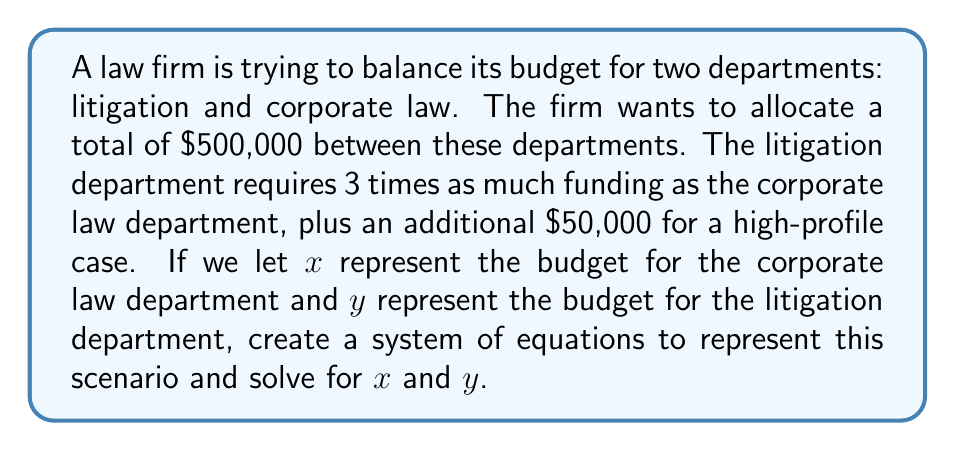Could you help me with this problem? Let's approach this step-by-step:

1) First, we need to set up our system of equations based on the given information:

   Equation 1: Total budget
   $x + y = 500000$

   Equation 2: Relationship between departments' budgets
   $y = 3x + 50000$

2) Now we have a system of two equations with two unknowns:

   $$\begin{cases}
   x + y = 500000 \\
   y = 3x + 50000
   \end{cases}$$

3) We can solve this system by substitution. Let's substitute the second equation into the first:

   $x + (3x + 50000) = 500000$

4) Simplify:

   $4x + 50000 = 500000$

5) Subtract 50000 from both sides:

   $4x = 450000$

6) Divide both sides by 4:

   $x = 112500$

7) Now that we know $x$, we can find $y$ by plugging $x$ back into either of our original equations. Let's use the second equation:

   $y = 3(112500) + 50000 = 337500 + 50000 = 387500$

8) Let's verify that these values satisfy our first equation:

   $112500 + 387500 = 500000$

   This checks out, confirming our solution is correct.
Answer: Corporate law department budget ($x$): $112,500
Litigation department budget ($y$): $387,500 